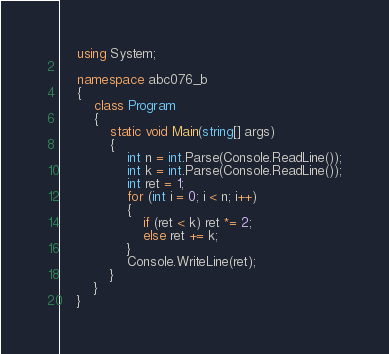Convert code to text. <code><loc_0><loc_0><loc_500><loc_500><_C#_>    using System;
     
    namespace abc076_b
    {
        class Program
        {
            static void Main(string[] args)
            {
                int n = int.Parse(Console.ReadLine());
                int k = int.Parse(Console.ReadLine());
                int ret = 1;
                for (int i = 0; i < n; i++)
                {
                    if (ret < k) ret *= 2;
                    else ret += k;
                }
                Console.WriteLine(ret);
            }
        }
    }</code> 